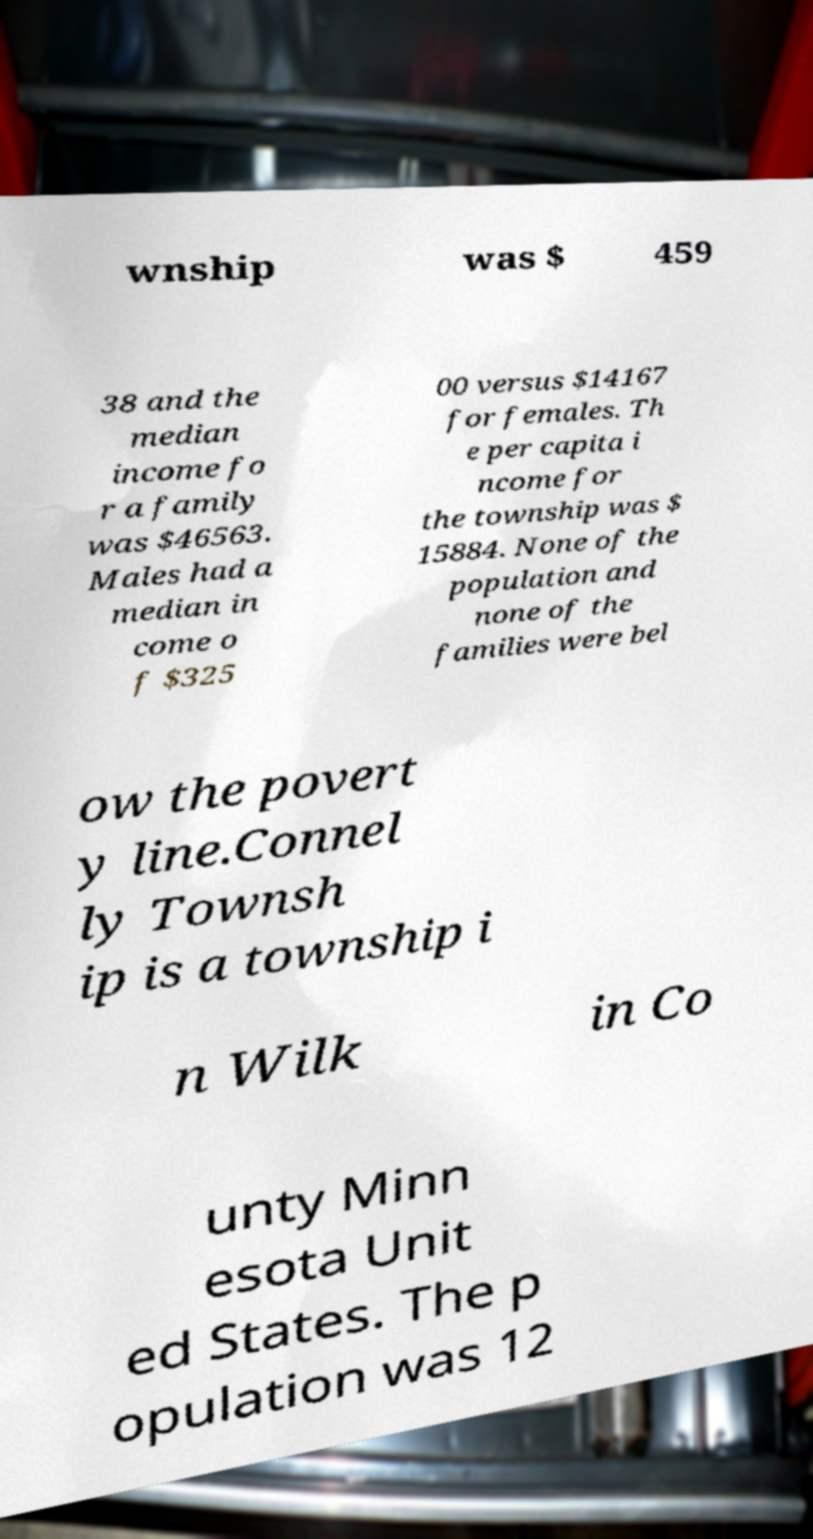Can you accurately transcribe the text from the provided image for me? wnship was $ 459 38 and the median income fo r a family was $46563. Males had a median in come o f $325 00 versus $14167 for females. Th e per capita i ncome for the township was $ 15884. None of the population and none of the families were bel ow the povert y line.Connel ly Townsh ip is a township i n Wilk in Co unty Minn esota Unit ed States. The p opulation was 12 